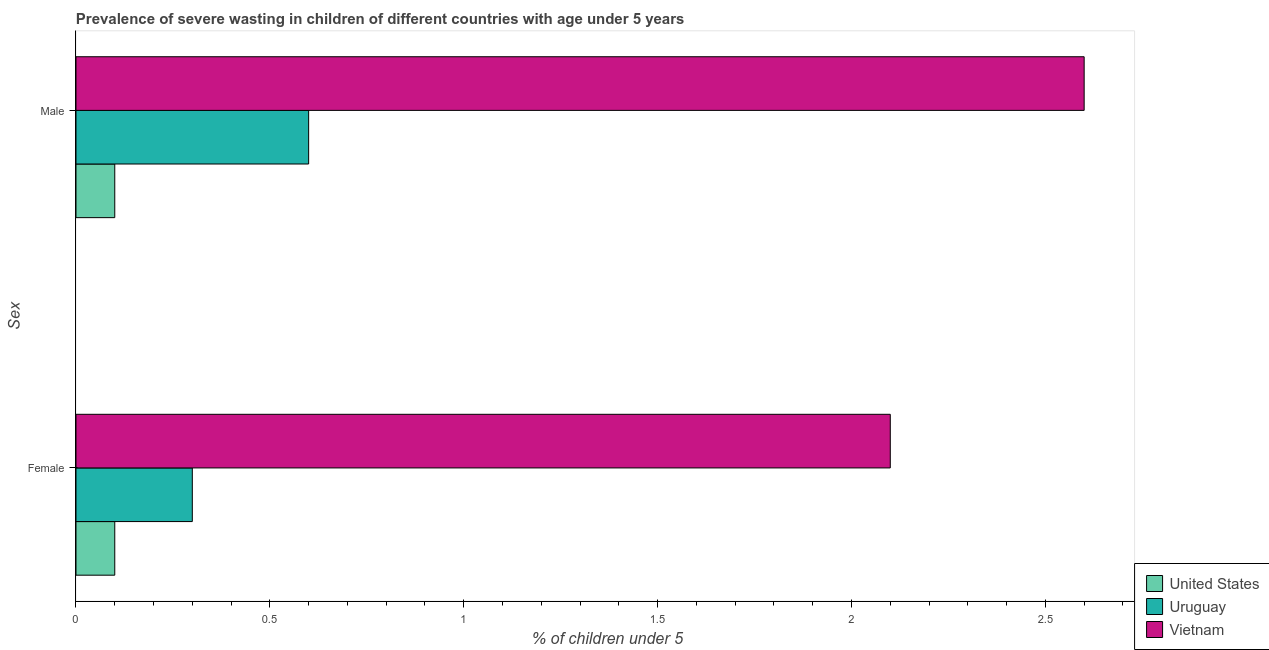How many different coloured bars are there?
Make the answer very short. 3. How many groups of bars are there?
Offer a very short reply. 2. Are the number of bars per tick equal to the number of legend labels?
Your response must be concise. Yes. How many bars are there on the 1st tick from the top?
Your answer should be very brief. 3. How many bars are there on the 2nd tick from the bottom?
Give a very brief answer. 3. What is the percentage of undernourished male children in Vietnam?
Provide a succinct answer. 2.6. Across all countries, what is the maximum percentage of undernourished female children?
Provide a succinct answer. 2.1. Across all countries, what is the minimum percentage of undernourished female children?
Give a very brief answer. 0.1. In which country was the percentage of undernourished female children maximum?
Keep it short and to the point. Vietnam. What is the total percentage of undernourished male children in the graph?
Keep it short and to the point. 3.3. What is the difference between the percentage of undernourished female children in Uruguay and that in United States?
Your answer should be compact. 0.2. What is the difference between the percentage of undernourished male children in Vietnam and the percentage of undernourished female children in Uruguay?
Your answer should be very brief. 2.3. What is the average percentage of undernourished male children per country?
Make the answer very short. 1.1. What is the difference between the percentage of undernourished male children and percentage of undernourished female children in United States?
Keep it short and to the point. 0. What is the ratio of the percentage of undernourished female children in Vietnam to that in United States?
Provide a succinct answer. 21. In how many countries, is the percentage of undernourished female children greater than the average percentage of undernourished female children taken over all countries?
Offer a very short reply. 1. What does the 3rd bar from the top in Male represents?
Give a very brief answer. United States. What does the 2nd bar from the bottom in Male represents?
Your answer should be very brief. Uruguay. Are all the bars in the graph horizontal?
Offer a very short reply. Yes. Are the values on the major ticks of X-axis written in scientific E-notation?
Your answer should be very brief. No. Does the graph contain any zero values?
Your answer should be compact. No. Where does the legend appear in the graph?
Your answer should be compact. Bottom right. How many legend labels are there?
Offer a very short reply. 3. How are the legend labels stacked?
Provide a short and direct response. Vertical. What is the title of the graph?
Give a very brief answer. Prevalence of severe wasting in children of different countries with age under 5 years. What is the label or title of the X-axis?
Make the answer very short.  % of children under 5. What is the label or title of the Y-axis?
Ensure brevity in your answer.  Sex. What is the  % of children under 5 of United States in Female?
Provide a short and direct response. 0.1. What is the  % of children under 5 of Uruguay in Female?
Offer a very short reply. 0.3. What is the  % of children under 5 in Vietnam in Female?
Your answer should be very brief. 2.1. What is the  % of children under 5 of United States in Male?
Offer a very short reply. 0.1. What is the  % of children under 5 of Uruguay in Male?
Make the answer very short. 0.6. What is the  % of children under 5 of Vietnam in Male?
Offer a very short reply. 2.6. Across all Sex, what is the maximum  % of children under 5 of United States?
Your answer should be very brief. 0.1. Across all Sex, what is the maximum  % of children under 5 in Uruguay?
Provide a short and direct response. 0.6. Across all Sex, what is the maximum  % of children under 5 in Vietnam?
Give a very brief answer. 2.6. Across all Sex, what is the minimum  % of children under 5 in United States?
Provide a short and direct response. 0.1. Across all Sex, what is the minimum  % of children under 5 in Uruguay?
Provide a short and direct response. 0.3. Across all Sex, what is the minimum  % of children under 5 in Vietnam?
Your answer should be compact. 2.1. What is the total  % of children under 5 of United States in the graph?
Provide a succinct answer. 0.2. What is the total  % of children under 5 of Uruguay in the graph?
Give a very brief answer. 0.9. What is the difference between the  % of children under 5 in Uruguay in Female and that in Male?
Ensure brevity in your answer.  -0.3. What is the difference between the  % of children under 5 of Vietnam in Female and that in Male?
Give a very brief answer. -0.5. What is the difference between the  % of children under 5 in United States in Female and the  % of children under 5 in Vietnam in Male?
Make the answer very short. -2.5. What is the average  % of children under 5 in United States per Sex?
Your answer should be compact. 0.1. What is the average  % of children under 5 in Uruguay per Sex?
Keep it short and to the point. 0.45. What is the average  % of children under 5 of Vietnam per Sex?
Give a very brief answer. 2.35. What is the difference between the  % of children under 5 of United States and  % of children under 5 of Vietnam in Female?
Ensure brevity in your answer.  -2. What is the difference between the  % of children under 5 in United States and  % of children under 5 in Uruguay in Male?
Provide a short and direct response. -0.5. What is the difference between the  % of children under 5 of United States and  % of children under 5 of Vietnam in Male?
Provide a succinct answer. -2.5. What is the ratio of the  % of children under 5 in United States in Female to that in Male?
Your response must be concise. 1. What is the ratio of the  % of children under 5 in Uruguay in Female to that in Male?
Provide a short and direct response. 0.5. What is the ratio of the  % of children under 5 of Vietnam in Female to that in Male?
Offer a very short reply. 0.81. What is the difference between the highest and the second highest  % of children under 5 of Vietnam?
Make the answer very short. 0.5. What is the difference between the highest and the lowest  % of children under 5 of Uruguay?
Your answer should be very brief. 0.3. 